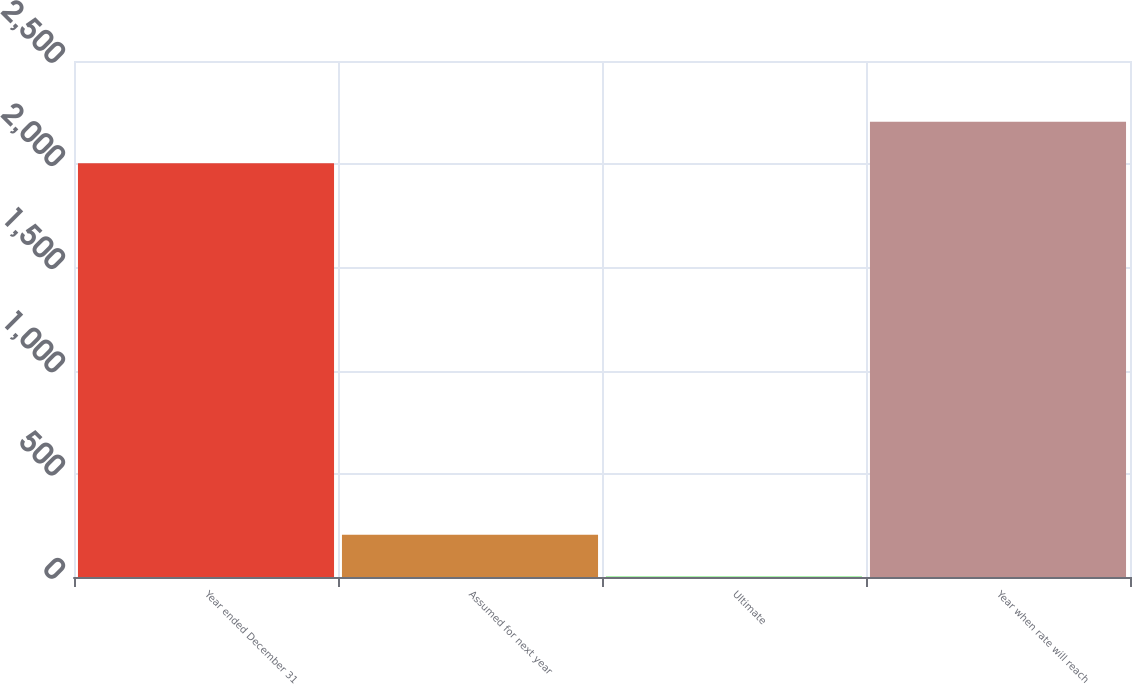Convert chart. <chart><loc_0><loc_0><loc_500><loc_500><bar_chart><fcel>Year ended December 31<fcel>Assumed for next year<fcel>Ultimate<fcel>Year when rate will reach<nl><fcel>2005<fcel>204.6<fcel>4<fcel>2205.6<nl></chart> 